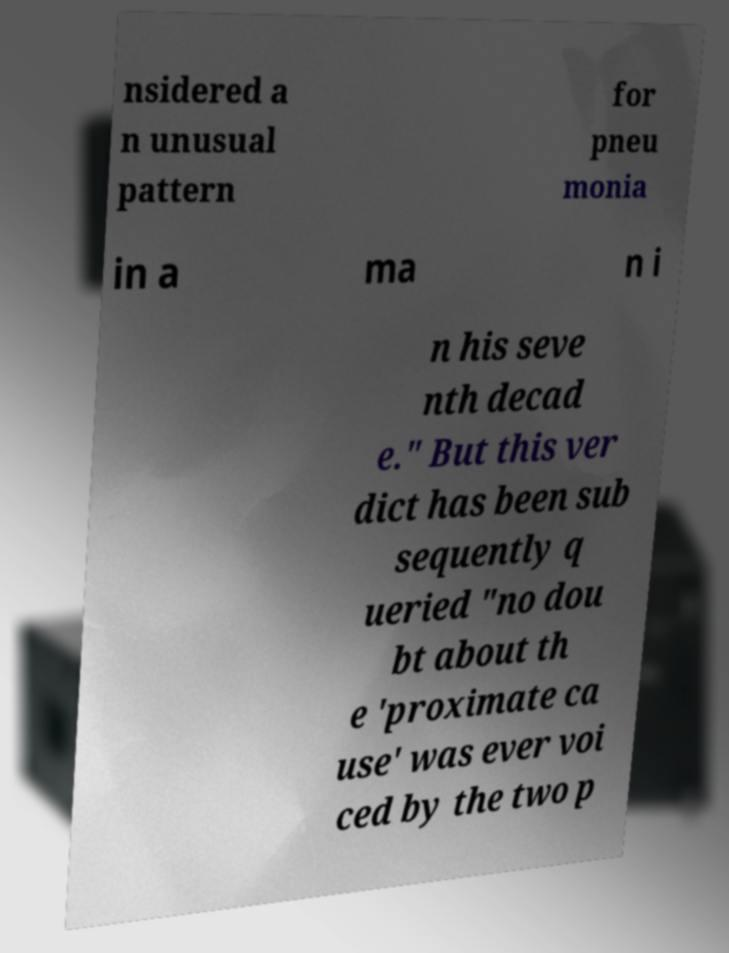Please read and relay the text visible in this image. What does it say? nsidered a n unusual pattern for pneu monia in a ma n i n his seve nth decad e." But this ver dict has been sub sequently q ueried "no dou bt about th e 'proximate ca use' was ever voi ced by the two p 